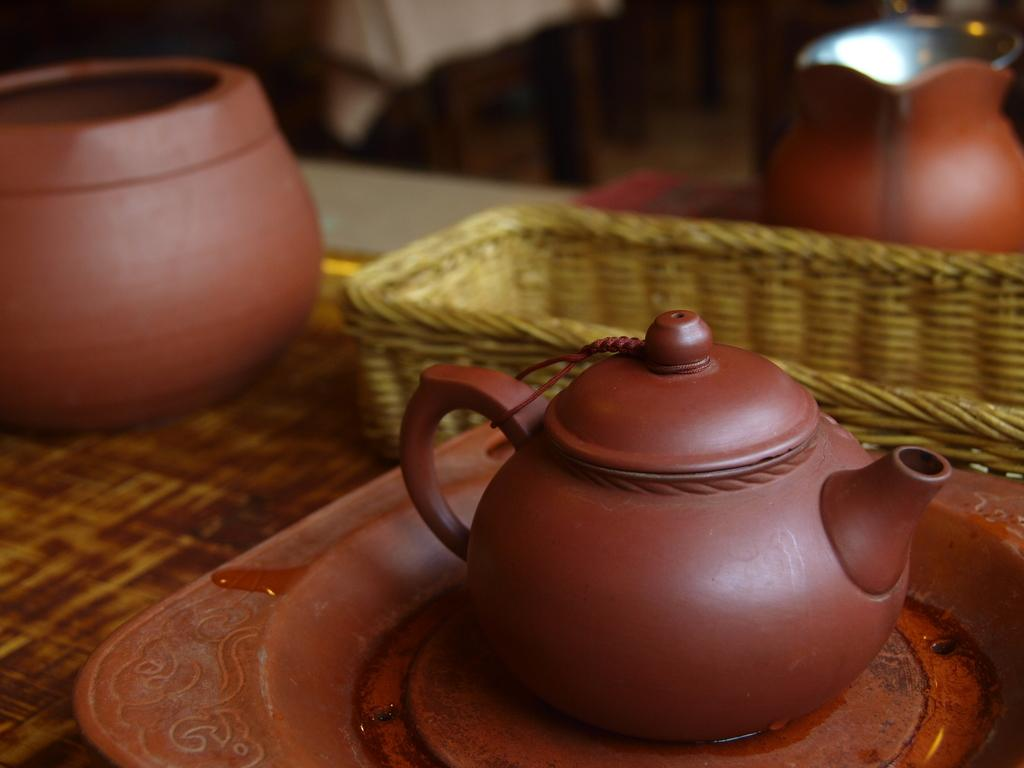What is located in the foreground of the image? There is a table in the foreground of the image. What items can be seen on the table? There are pots, a tray, and a basket on the table. Can you describe any other objects visible in the image? There are other objects visible in the background of the image. What type of paper is being processed by the hands in the image? There are no hands or paper present in the image. 